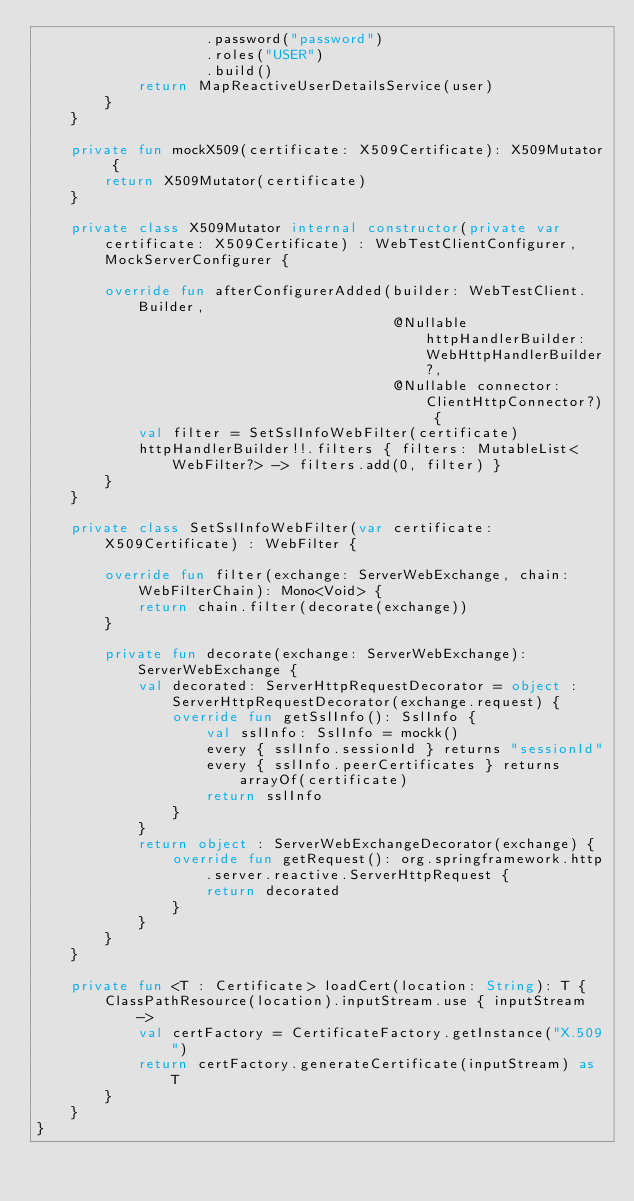<code> <loc_0><loc_0><loc_500><loc_500><_Kotlin_>                    .password("password")
                    .roles("USER")
                    .build()
            return MapReactiveUserDetailsService(user)
        }
    }

    private fun mockX509(certificate: X509Certificate): X509Mutator {
        return X509Mutator(certificate)
    }

    private class X509Mutator internal constructor(private var certificate: X509Certificate) : WebTestClientConfigurer, MockServerConfigurer {

        override fun afterConfigurerAdded(builder: WebTestClient.Builder,
                                          @Nullable httpHandlerBuilder: WebHttpHandlerBuilder?,
                                          @Nullable connector: ClientHttpConnector?) {
            val filter = SetSslInfoWebFilter(certificate)
            httpHandlerBuilder!!.filters { filters: MutableList<WebFilter?> -> filters.add(0, filter) }
        }
    }

    private class SetSslInfoWebFilter(var certificate: X509Certificate) : WebFilter {

        override fun filter(exchange: ServerWebExchange, chain: WebFilterChain): Mono<Void> {
            return chain.filter(decorate(exchange))
        }

        private fun decorate(exchange: ServerWebExchange): ServerWebExchange {
            val decorated: ServerHttpRequestDecorator = object : ServerHttpRequestDecorator(exchange.request) {
                override fun getSslInfo(): SslInfo {
                    val sslInfo: SslInfo = mockk()
                    every { sslInfo.sessionId } returns "sessionId"
                    every { sslInfo.peerCertificates } returns arrayOf(certificate)
                    return sslInfo
                }
            }
            return object : ServerWebExchangeDecorator(exchange) {
                override fun getRequest(): org.springframework.http.server.reactive.ServerHttpRequest {
                    return decorated
                }
            }
        }
    }

    private fun <T : Certificate> loadCert(location: String): T {
        ClassPathResource(location).inputStream.use { inputStream ->
            val certFactory = CertificateFactory.getInstance("X.509")
            return certFactory.generateCertificate(inputStream) as T
        }
    }
}
</code> 